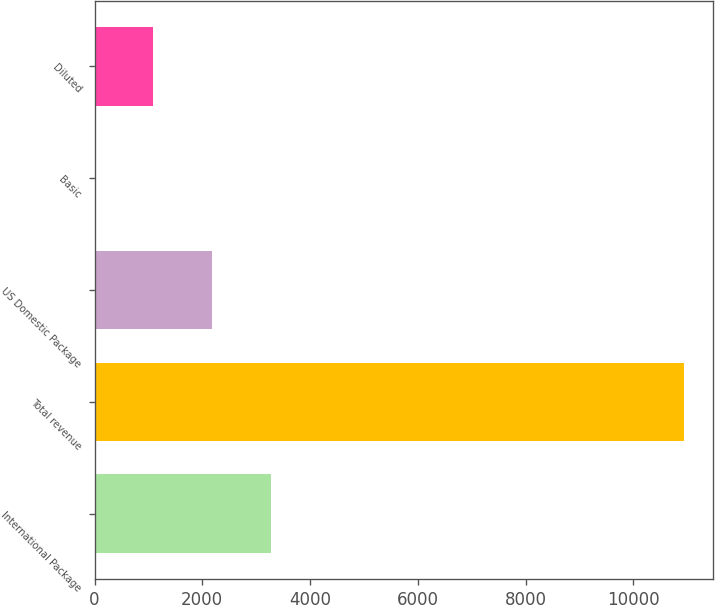Convert chart to OTSL. <chart><loc_0><loc_0><loc_500><loc_500><bar_chart><fcel>International Package<fcel>Total revenue<fcel>US Domestic Package<fcel>Basic<fcel>Diluted<nl><fcel>3281.68<fcel>10938<fcel>2187.92<fcel>0.4<fcel>1094.16<nl></chart> 